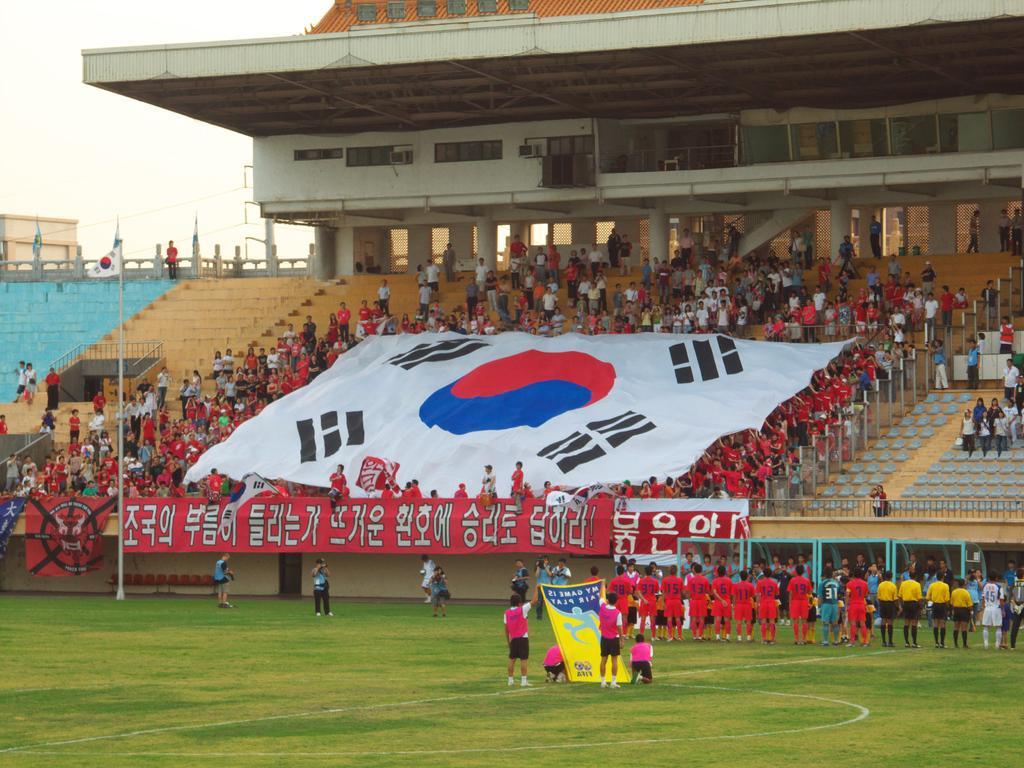Can you describe this image briefly? As we can see in the image there are group of people, stairs, banners, windows, cloth, grass, flag and at the top there is sky. 